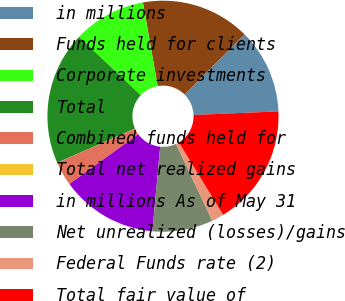Convert chart to OTSL. <chart><loc_0><loc_0><loc_500><loc_500><pie_chart><fcel>in millions<fcel>Funds held for clients<fcel>Corporate investments<fcel>Total<fcel>Combined funds held for<fcel>Total net realized gains<fcel>in millions As of May 31<fcel>Net unrealized (losses)/gains<fcel>Federal Funds rate (2)<fcel>Total fair value of<nl><fcel>11.86%<fcel>15.25%<fcel>10.17%<fcel>18.64%<fcel>3.39%<fcel>0.0%<fcel>13.56%<fcel>8.47%<fcel>1.7%<fcel>16.95%<nl></chart> 